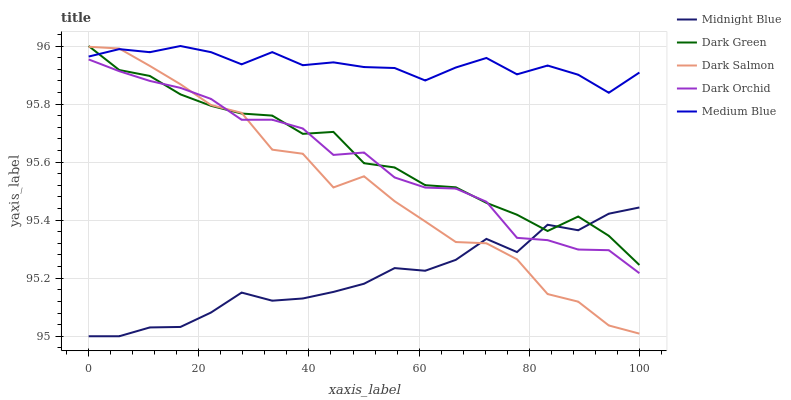Does Midnight Blue have the minimum area under the curve?
Answer yes or no. Yes. Does Medium Blue have the maximum area under the curve?
Answer yes or no. Yes. Does Dark Salmon have the minimum area under the curve?
Answer yes or no. No. Does Dark Salmon have the maximum area under the curve?
Answer yes or no. No. Is Dark Orchid the smoothest?
Answer yes or no. Yes. Is Dark Salmon the roughest?
Answer yes or no. Yes. Is Midnight Blue the smoothest?
Answer yes or no. No. Is Midnight Blue the roughest?
Answer yes or no. No. Does Midnight Blue have the lowest value?
Answer yes or no. Yes. Does Dark Salmon have the lowest value?
Answer yes or no. No. Does Dark Green have the highest value?
Answer yes or no. Yes. Does Dark Salmon have the highest value?
Answer yes or no. No. Is Midnight Blue less than Medium Blue?
Answer yes or no. Yes. Is Medium Blue greater than Midnight Blue?
Answer yes or no. Yes. Does Dark Green intersect Dark Orchid?
Answer yes or no. Yes. Is Dark Green less than Dark Orchid?
Answer yes or no. No. Is Dark Green greater than Dark Orchid?
Answer yes or no. No. Does Midnight Blue intersect Medium Blue?
Answer yes or no. No. 